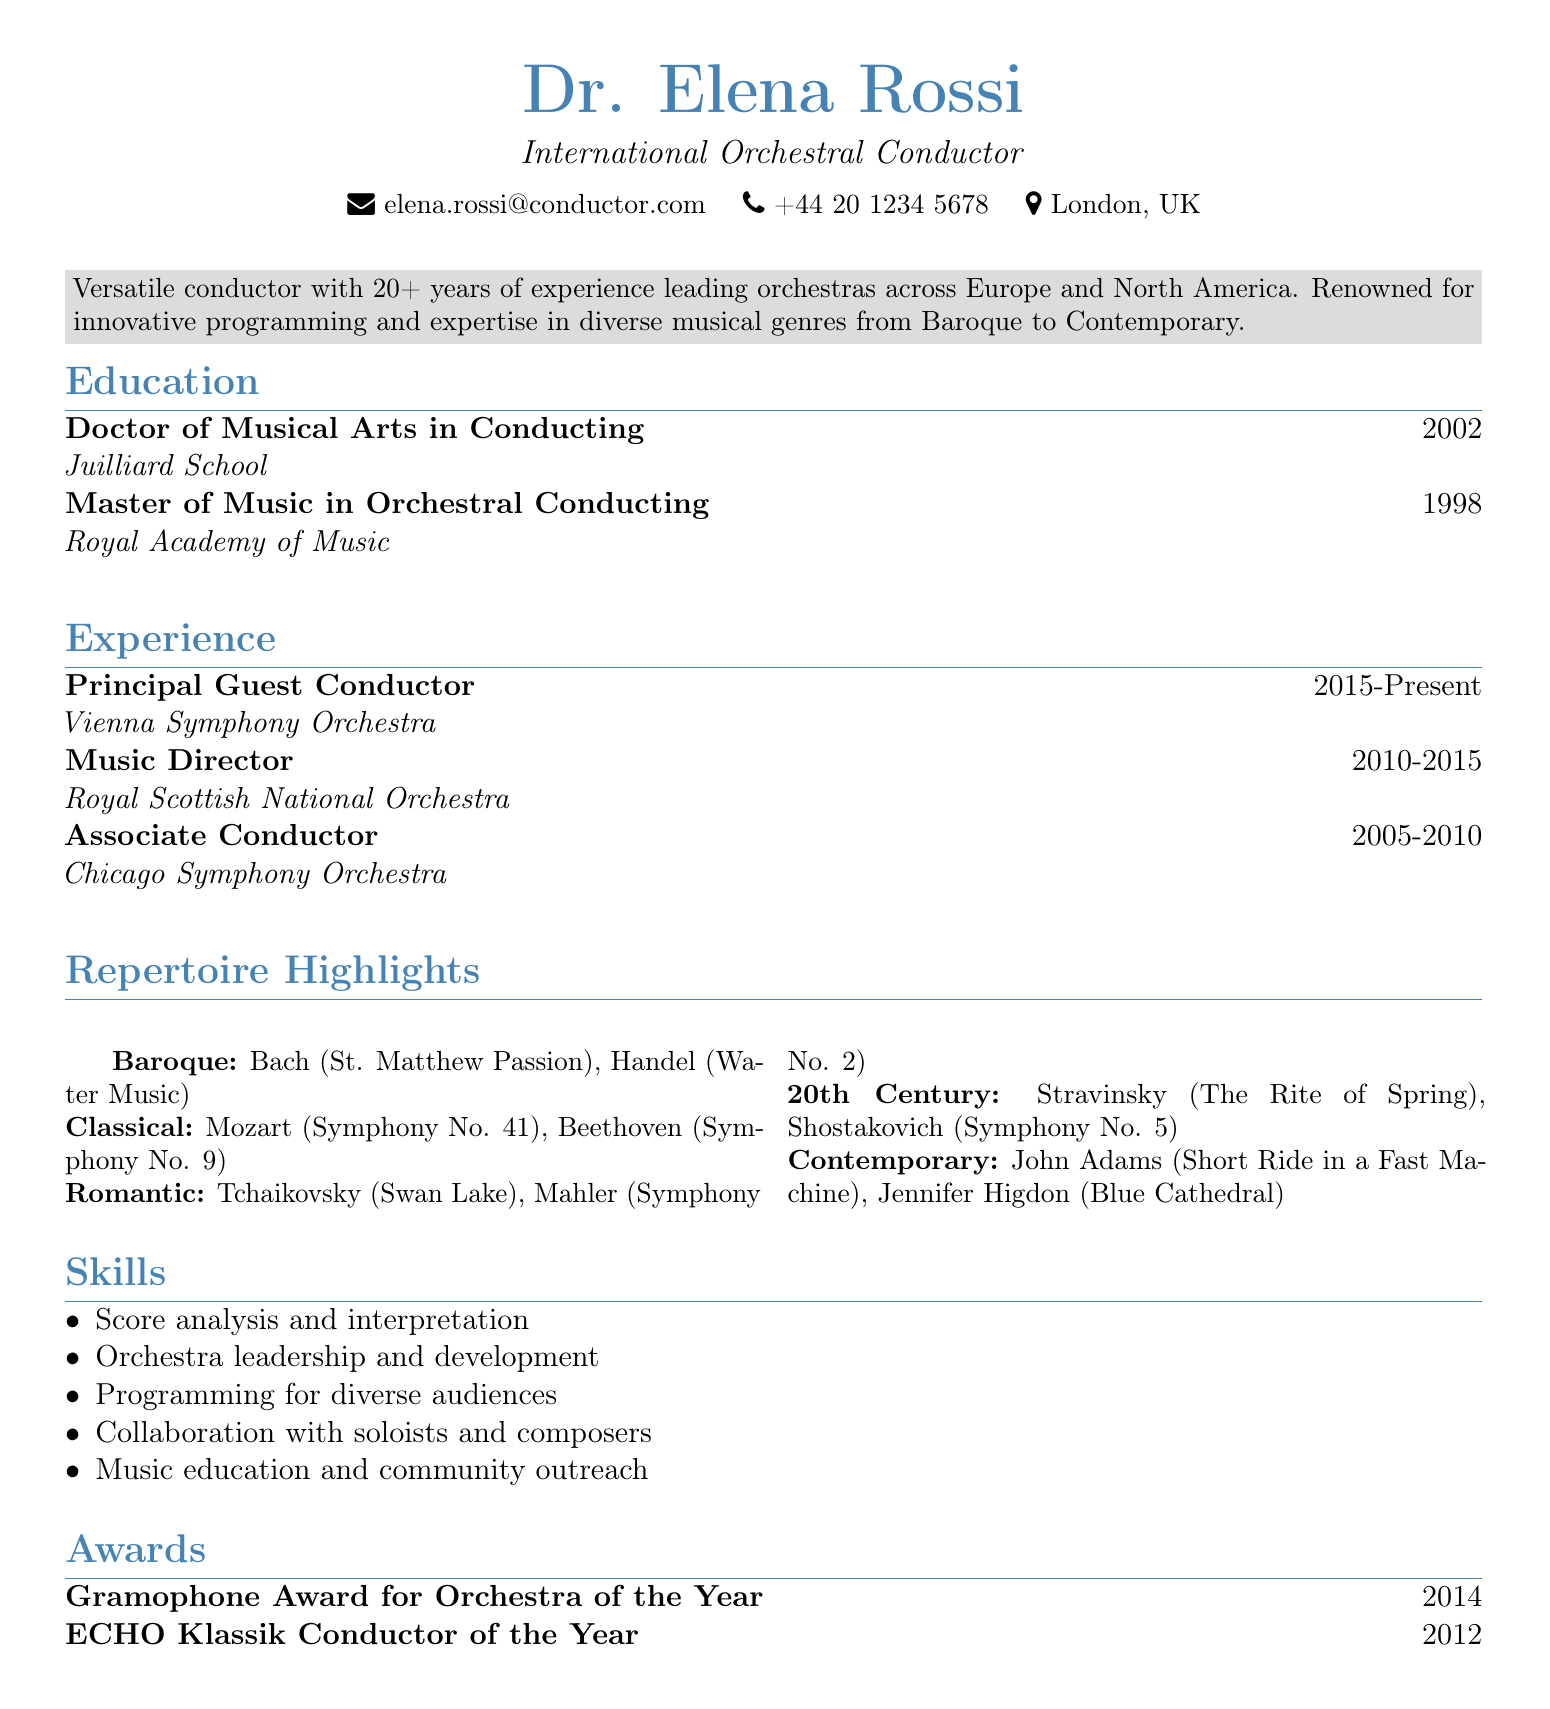What is the title of Dr. Elena Rossi? The title is explicitly stated at the top of the resume under her name.
Answer: International Orchestral Conductor Which institution did Dr. Rossi obtain her Doctor of Musical Arts from? This information is found in the education section of the document.
Answer: Juilliard School What year did Dr. Rossi become the Principal Guest Conductor of the Vienna Symphony Orchestra? The duration of her position is listed clearly in the experience section.
Answer: 2015 Name one work from the Romantic repertoire listed in the document. The repertoire section specifies several works across different periods.
Answer: Tchaikovsky: Swan Lake How many years of experience does Dr. Rossi have as a conductor? The summary section states her total years of experience leading orchestras.
Answer: 20+ Identify one skill mentioned in the resume. Skills are listed distinctly in their own section of the document.
Answer: Score analysis and interpretation What award did Dr. Rossi win in 2012? The awards section clearly outlines the titles and years associated with her achievements.
Answer: ECHO Klassik Conductor of the Year Which two contemporary works are highlighted in her repertoire? The document lists specific works under each period, including contemporary pieces.
Answer: John Adams: Short Ride in a Fast Machine, Jennifer Higdon: Blue Cathedral What are the two cities where Dr. Rossi has worked as a conductor? The experience section indicates the orchestras, which are based in identifiable cities.
Answer: Vienna, Chicago 